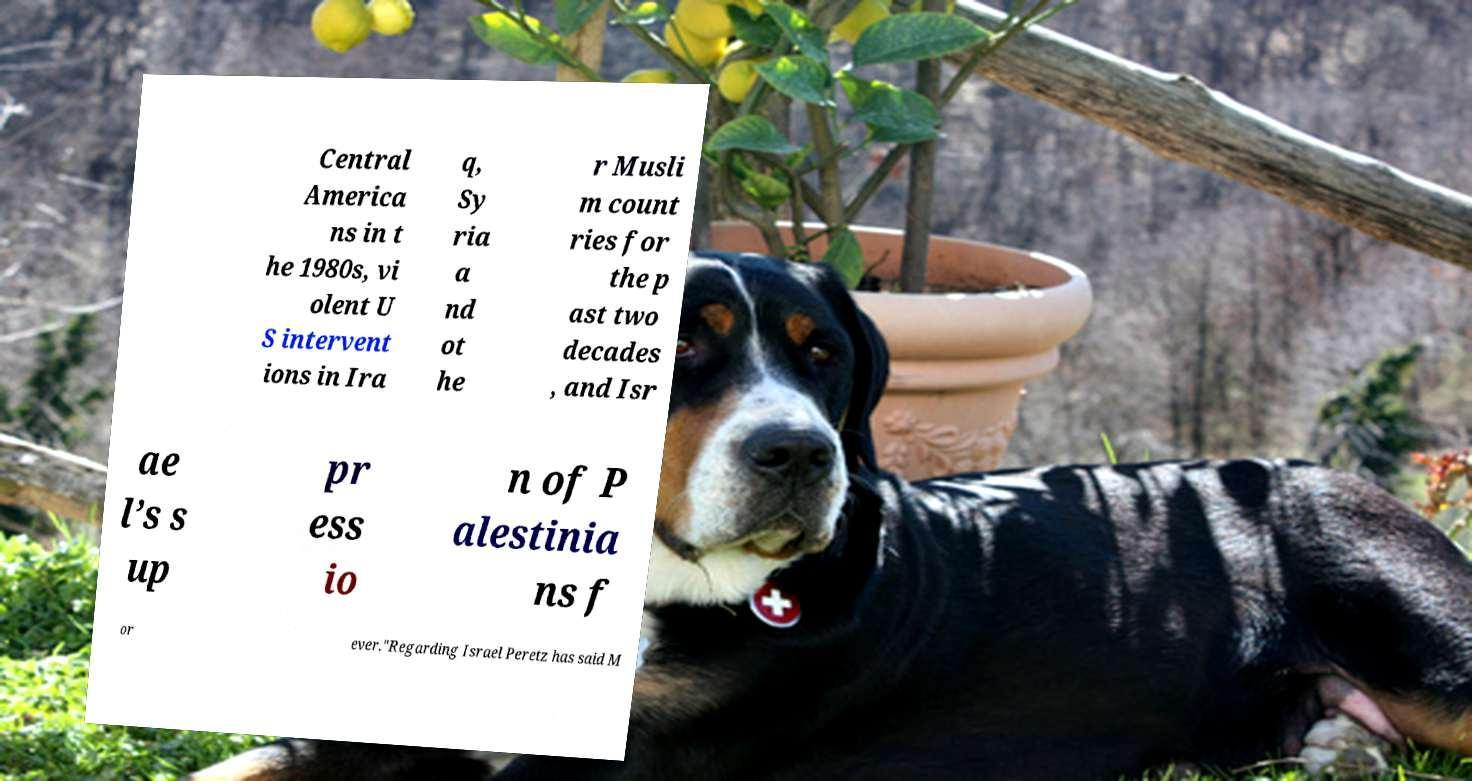Could you assist in decoding the text presented in this image and type it out clearly? Central America ns in t he 1980s, vi olent U S intervent ions in Ira q, Sy ria a nd ot he r Musli m count ries for the p ast two decades , and Isr ae l’s s up pr ess io n of P alestinia ns f or ever."Regarding Israel Peretz has said M 